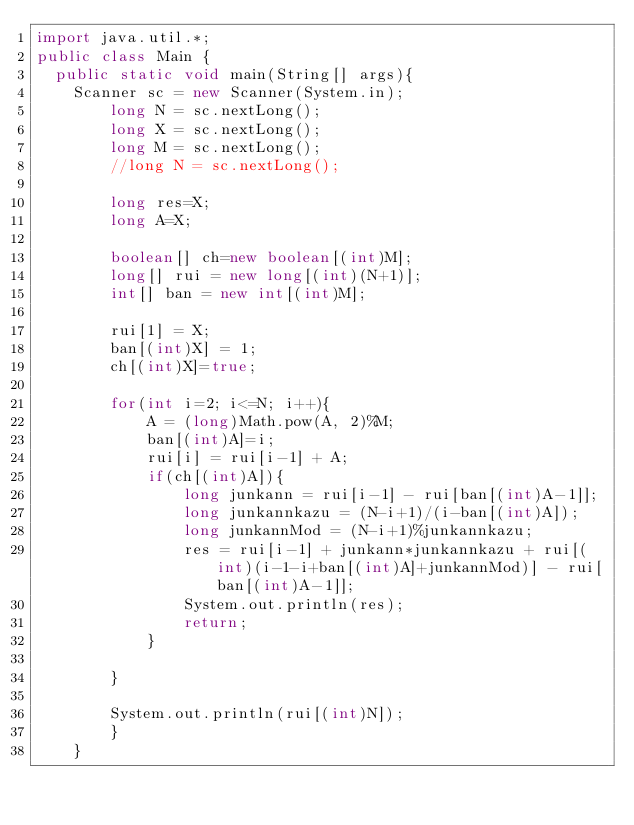Convert code to text. <code><loc_0><loc_0><loc_500><loc_500><_Java_>import java.util.*;
public class Main {
	public static void main(String[] args){
		Scanner sc = new Scanner(System.in);
        long N = sc.nextLong();
        long X = sc.nextLong();
        long M = sc.nextLong();
        //long N = sc.nextLong();

        long res=X;
        long A=X;

        boolean[] ch=new boolean[(int)M];
        long[] rui = new long[(int)(N+1)];
        int[] ban = new int[(int)M];
        
        rui[1] = X;
        ban[(int)X] = 1;
        ch[(int)X]=true;

        for(int i=2; i<=N; i++){
            A = (long)Math.pow(A, 2)%M;
            ban[(int)A]=i;
            rui[i] = rui[i-1] + A;
            if(ch[(int)A]){
                long junkann = rui[i-1] - rui[ban[(int)A-1]];
                long junkannkazu = (N-i+1)/(i-ban[(int)A]);
                long junkannMod = (N-i+1)%junkannkazu;
                res = rui[i-1] + junkann*junkannkazu + rui[(int)(i-1-i+ban[(int)A]+junkannMod)] - rui[ban[(int)A-1]];
                System.out.println(res);
                return;
            }
            
        }
        
        System.out.println(rui[(int)N]);
        }
    }</code> 